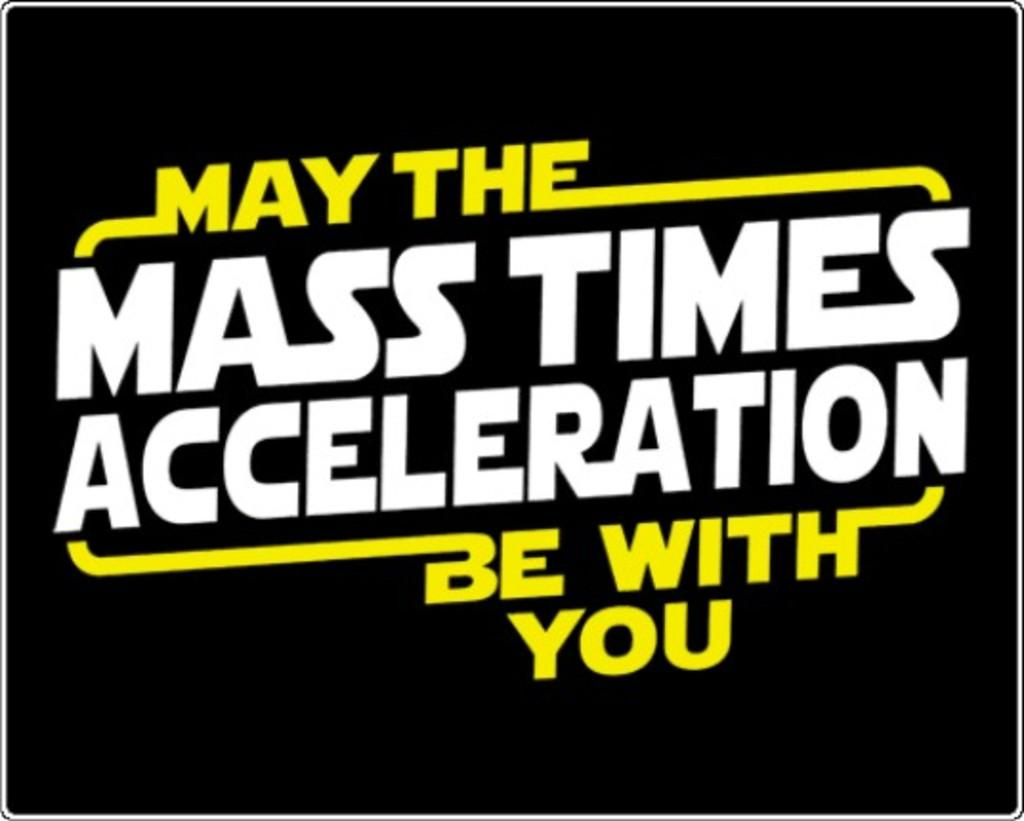<image>
Offer a succinct explanation of the picture presented. a quote with a black background that has the word acceleration in it 